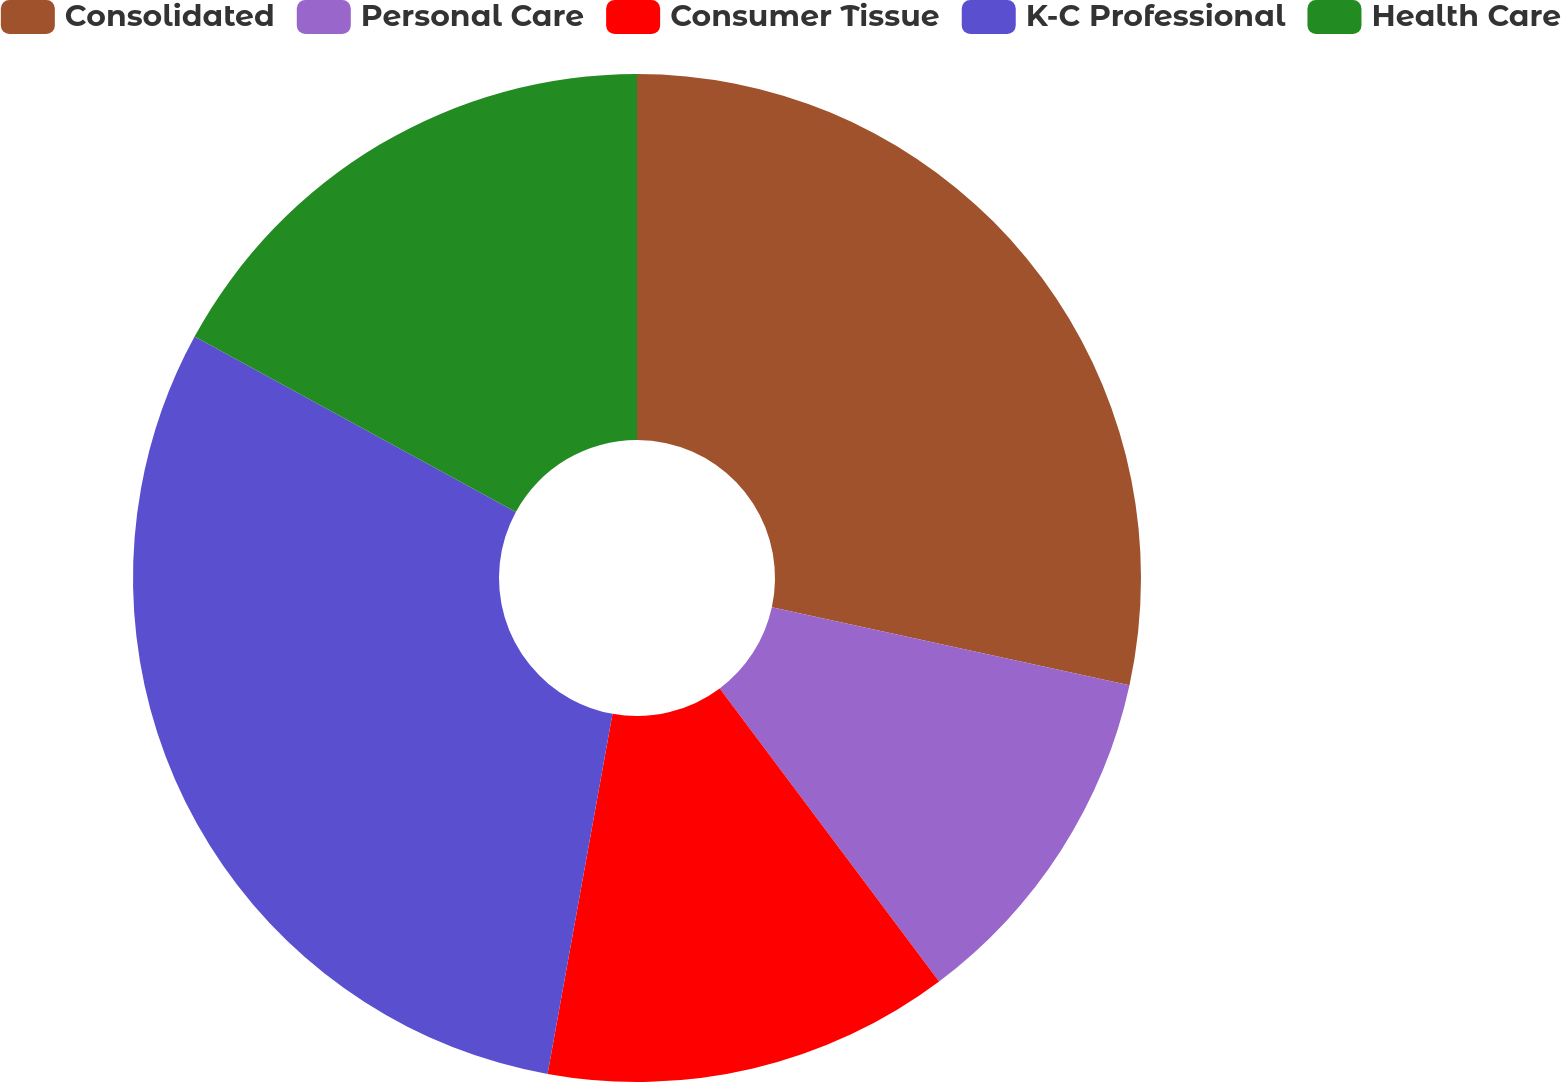<chart> <loc_0><loc_0><loc_500><loc_500><pie_chart><fcel>Consolidated<fcel>Personal Care<fcel>Consumer Tissue<fcel>K-C Professional<fcel>Health Care<nl><fcel>28.41%<fcel>11.36%<fcel>13.07%<fcel>30.11%<fcel>17.05%<nl></chart> 